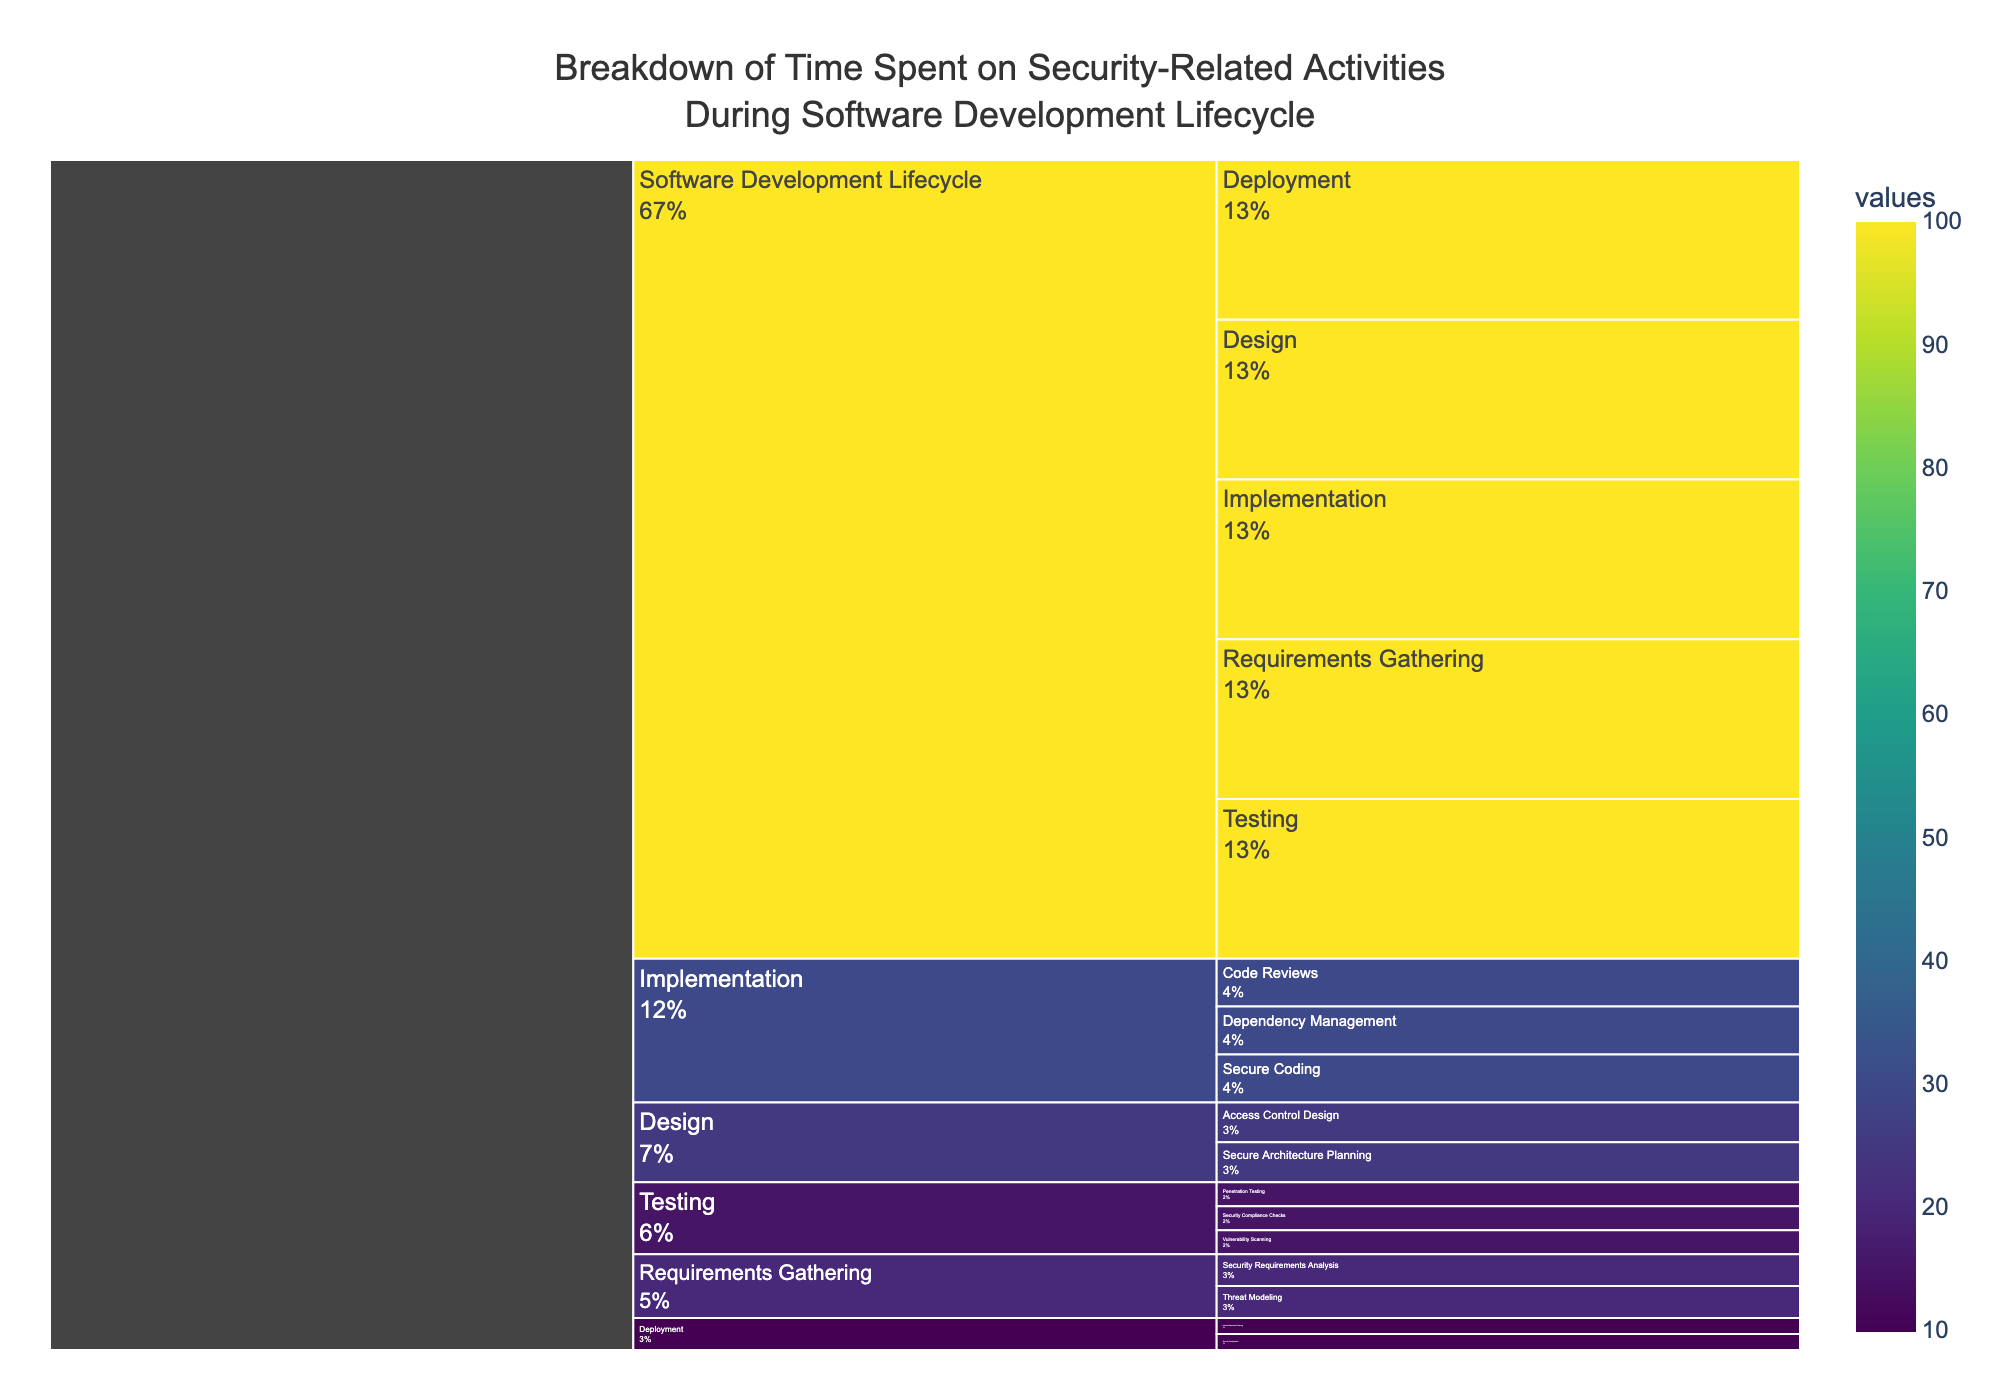What is the title of the icicle chart? The title of the icicle chart is displayed prominently at the top of the figure.
Answer: Breakdown of Time Spent on Security-Related Activities During Software Development Lifecycle Which activity takes the most time in the software development lifecycle? By examining the different segments of the icicle chart representing each main activity (Requirements Gathering, Design, Implementation, Testing, Deployment), we find the segment with the largest size.
Answer: Implementation What is the percentage of time spent on Secure Coding relative to the entire software development lifecycle? The plot shows percentage labels for each sub-activity. Locate the percentage associated with Secure Coding.
Answer: 12% How does the time spent on Testing compare to the time spent on Deployment? The chart sections for Testing and Deployment can be visually compared. Testing is represented by a larger segment than Deployment, indicating more time spent.
Answer: Testing has 15, Deployment has 10 Summing up Secure Architecture Planning and Access Control Design, how much time is spent on Design-related activities? Secure Architecture Planning spends 15 units and Access Control Design spends 10 units. Adding them gives the total time for Design-related activities.
Answer: 25 units What is the least time-consuming activity in the software development lifecycle based on the chart? Identify the smallest segment among the main activities. Deployment appears as the smallest slice.
Answer: Deployment How much time is spent on security-related activities in Requirements Gathering? Add the times for Threat Modeling and Security Requirements Analysis (8 and 12).
Answer: 20 units Which sub-activity within Testing consumes the most time? Compare the segments for Vulnerability Scanning, Penetration Testing, and Security Compliance Checks. Penetration Testing has the largest segment.
Answer: Penetration Testing What is the cumulative time spent on Security Configuration and Incident Response Planning during Deployment? Add the times for Security Configuration and Incident Response Planning (6 and 4).
Answer: 10 units Is the time spent on Code Reviews greater than or less than the time spent on Vulnerability Scanning? Compare the segments for Code Reviews (10) and Vulnerability Scanning (5). Code Reviews is larger.
Answer: Greater 